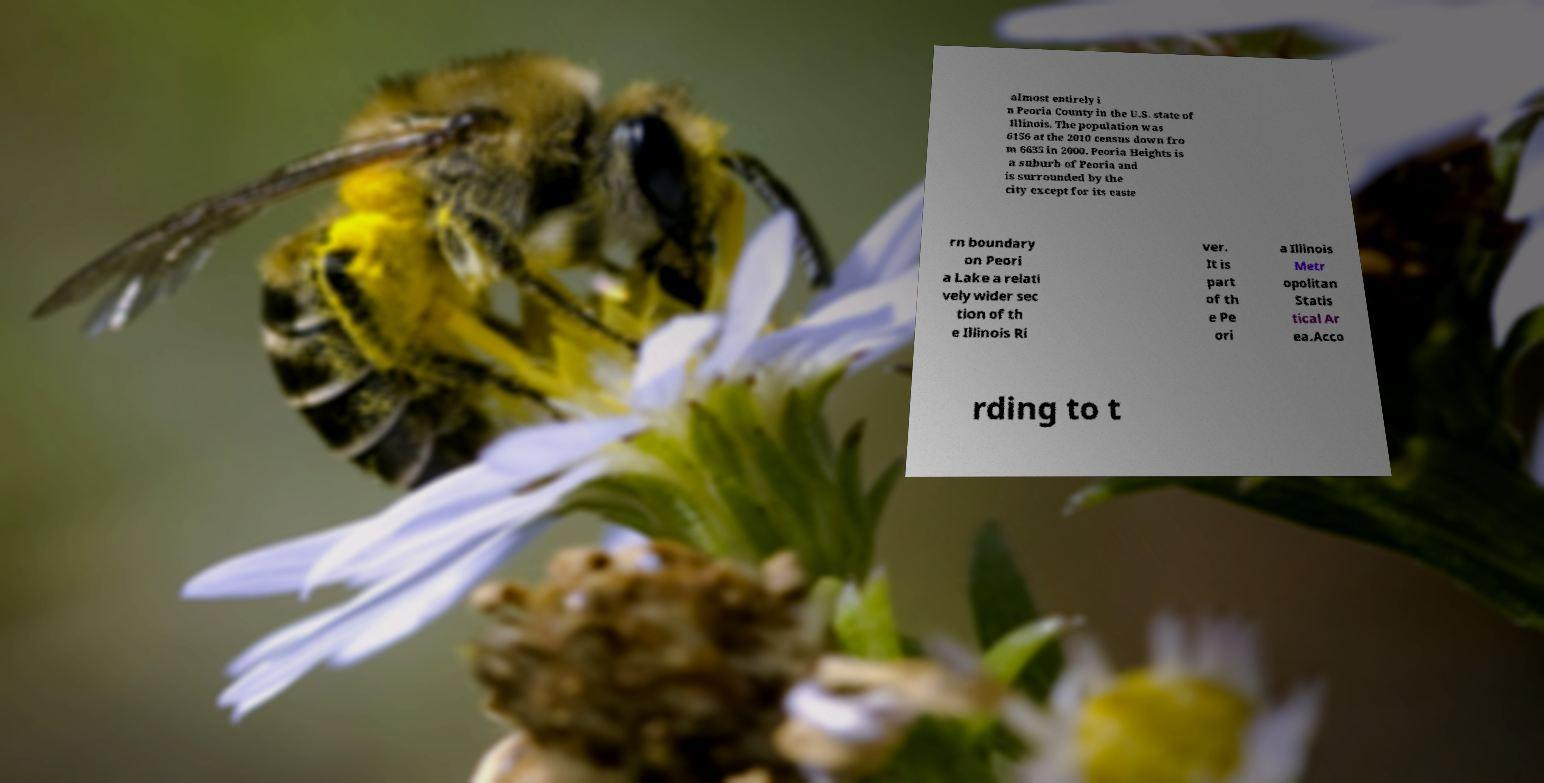There's text embedded in this image that I need extracted. Can you transcribe it verbatim? almost entirely i n Peoria County in the U.S. state of Illinois. The population was 6156 at the 2010 census down fro m 6635 in 2000. Peoria Heights is a suburb of Peoria and is surrounded by the city except for its easte rn boundary on Peori a Lake a relati vely wider sec tion of th e Illinois Ri ver. It is part of th e Pe ori a Illinois Metr opolitan Statis tical Ar ea.Acco rding to t 